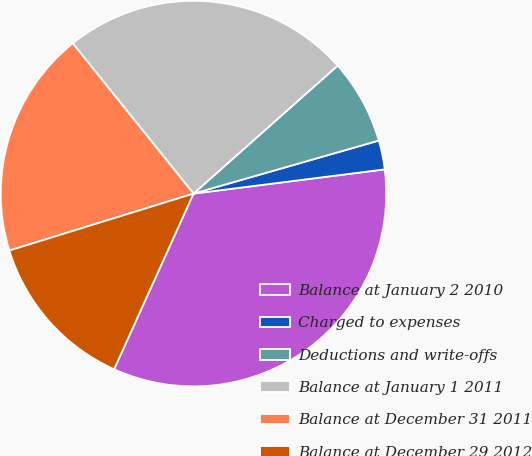Convert chart to OTSL. <chart><loc_0><loc_0><loc_500><loc_500><pie_chart><fcel>Balance at January 2 2010<fcel>Charged to expenses<fcel>Deductions and write-offs<fcel>Balance at January 1 2011<fcel>Balance at December 31 2011<fcel>Balance at December 29 2012<nl><fcel>33.76%<fcel>2.43%<fcel>7.12%<fcel>24.21%<fcel>19.0%<fcel>13.47%<nl></chart> 